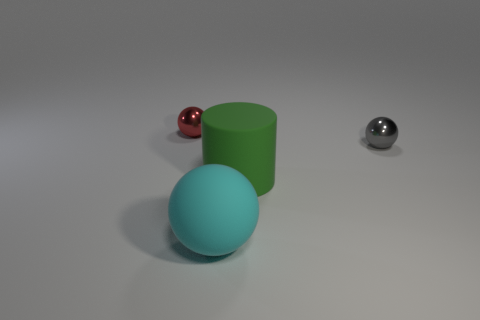How many other objects are there of the same shape as the green rubber thing?
Your answer should be compact. 0. What color is the object that is on the left side of the tiny gray ball and on the right side of the large cyan sphere?
Your response must be concise. Green. What is the color of the large sphere?
Your answer should be compact. Cyan. Do the small gray ball and the object in front of the green cylinder have the same material?
Provide a succinct answer. No. The object that is the same material as the gray ball is what shape?
Your answer should be compact. Sphere. What color is the cylinder that is the same size as the cyan ball?
Your answer should be compact. Green. There is a shiny thing that is left of the gray thing; is its size the same as the gray thing?
Your response must be concise. Yes. Is the rubber ball the same color as the big cylinder?
Give a very brief answer. No. What number of big matte objects are there?
Make the answer very short. 2. How many cylinders are either large cyan rubber objects or small shiny objects?
Provide a short and direct response. 0. 